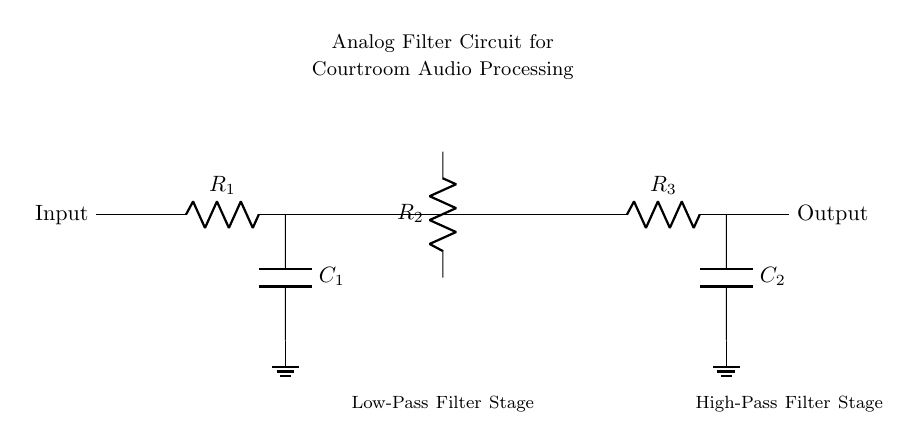What is the function of R1? R1 is part of the low-pass filter stage and limits the current flowing into the capacitor C1. It helps shape the frequency response of the circuit.
Answer: limits current What type of filter is represented in this circuit? The circuit includes both a low-pass filter and a high-pass filter, as indicated by the components R1, C1 for the low-pass stage, and R3, C2 for the high-pass stage.
Answer: analog filter What does the op-amp do in this circuit? The op-amp amplifies the voltage signal received from the previous stage, providing gain to the circuit, allowing for a stronger output signal.
Answer: amplifies signal What is the role of C1? C1 is a capacitor that blocks DC voltage and allows AC signals to pass through, crucial for the low-pass filtering function by removing high-frequency noise.
Answer: blocks DC How many resistor components are in this circuit? There are three resistors labeled R1, R2, and R3, contributing to the different stages of filtering in the circuit.
Answer: three What is the output of the circuit? The output is the amplified and filtered audio signal, expected to have reduced noise and improved clarity for courtroom recording purposes.
Answer: filtered audio What determines the cutoff frequency of this filter? The cutoff frequency is determined by the values of the resistors and capacitors in the circuit, particularly R1 with C1 for the low-pass filter and R3 with C2 for the high-pass filter.
Answer: resistor and capacitor values 